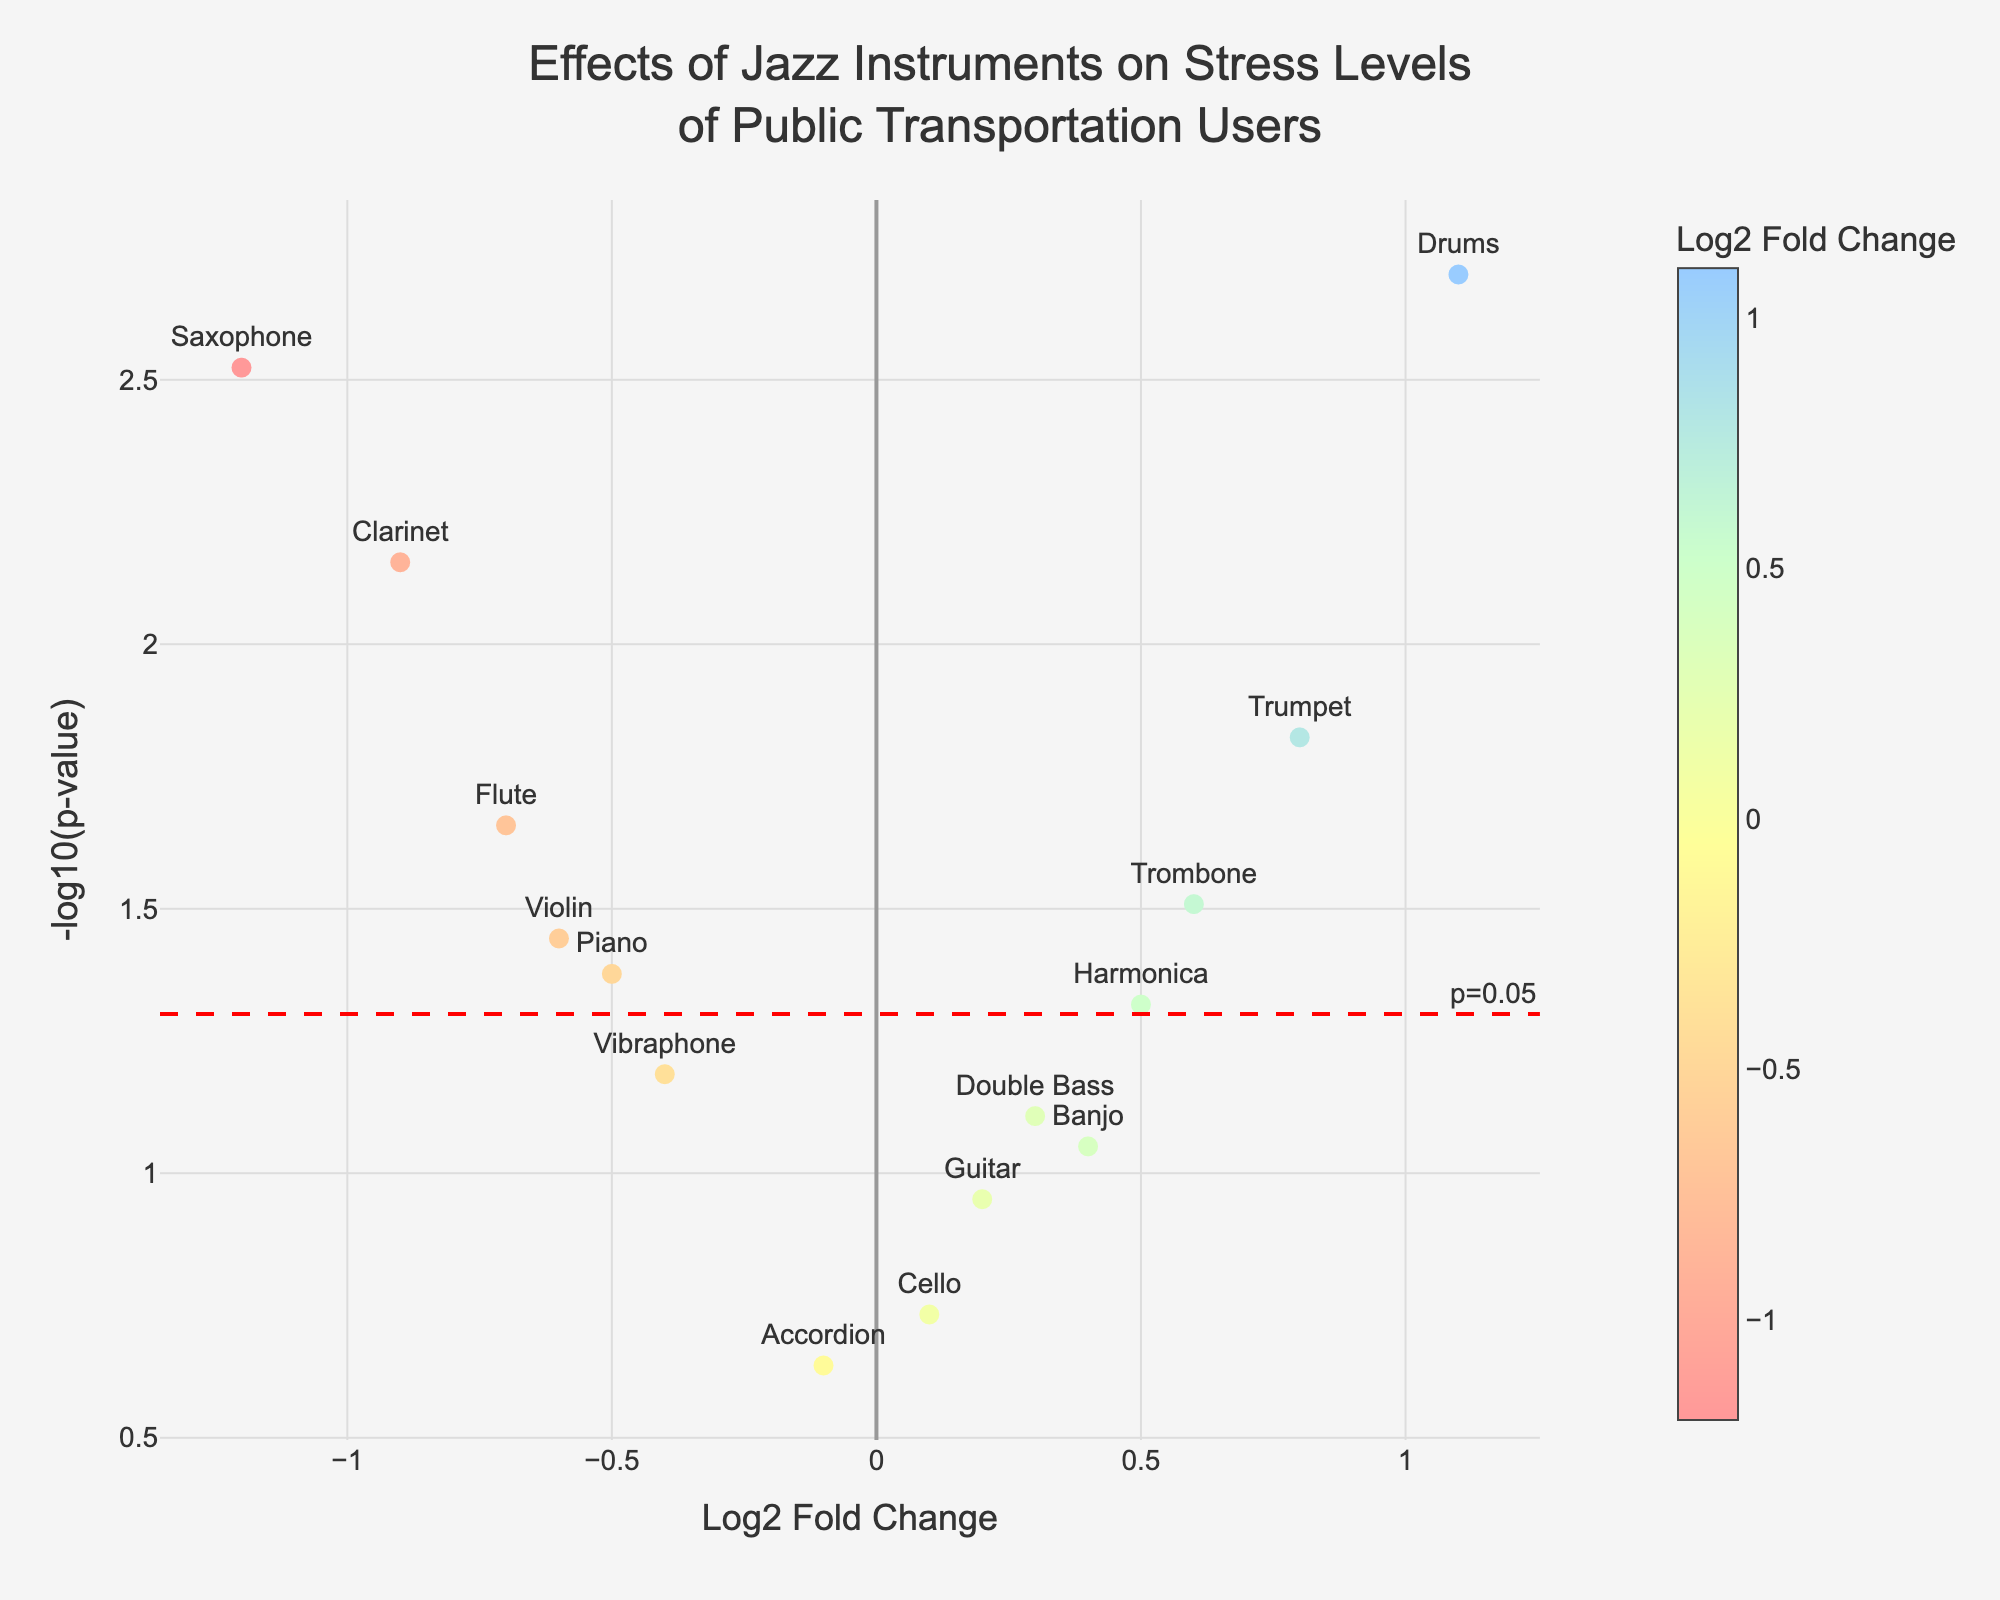What is the title of the figure? The title is always located at the top of the figure. In this case, it describes the overall purpose of the plot.
Answer: Effects of Jazz Instruments on Stress Levels of Public Transportation Users Which instrument is associated with the highest positive Log2 Fold Change? By looking at the x-axis for the highest positive Log2 Fold Change and reading the corresponding label, we identify the instrument.
Answer: Drums Which instrument has the lowest p-value? The p-value is represented on the y-axis as -log10(p-value). A smaller p-value will be higher on this axis. Identify the highest point on the y-axis and note the instrument associated with that point.
Answer: Drums What does the horizontal red dashed line indicate? The horizontal red dashed line represents the threshold for significance in terms of p-value. Since the line is located at -log10(0.05), it means any point above this line has a p-value less than 0.05, which is considered statistically significant.
Answer: p=0.05 threshold How many instruments have p-values less than 0.05? Points above the red dashed horizontal line have p-values less than 0.05. Count these points to determine how many meet this criterion.
Answer: 8 Which instrument has the largest negative Log2 Fold Change and is statistically significant? To answer this, find the most negative value on the x-axis and check if its corresponding y value is above the red dashed line (indicating statistical significance).
Answer: Saxophone What instrument shows the least effect on stress levels (i.e., Log2 Fold Change close to zero) and is not statistically significant? Instruments with Log2 Fold Change close to zero will be near the origin on the x-axis. Among these, the ones below the red dashed line are not statistically significant. Find the closest point near zero x-axis below the dashed line.
Answer: Accordion Compare the stress reduction effects of the Saxophone to the Flute. Look at both instruments on the x-axis. The Saxophone has a more negative Log2 Fold Change than the Flute, meaning it has a stronger stress-reducing effect.
Answer: Saxophone has a stronger stress-reducing effect Which instruments have p-values just above 0.05 indicated by points just below the red dashed line? Points just below the red dashed line have p-values slightly greater than 0.05. Identify these points and their corresponding instruments.
Answer: Double Bass, Vibraphone, Banjo 